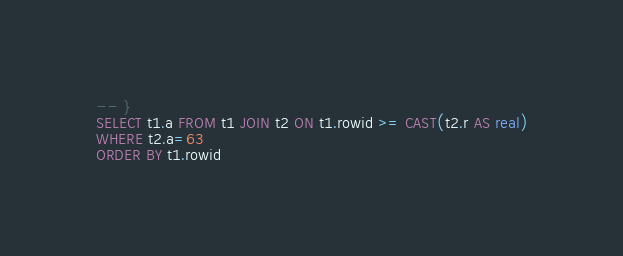Convert code to text. <code><loc_0><loc_0><loc_500><loc_500><_SQL_>-- }
SELECT t1.a FROM t1 JOIN t2 ON t1.rowid >= CAST(t2.r AS real)
WHERE t2.a=63
ORDER BY t1.rowid</code> 